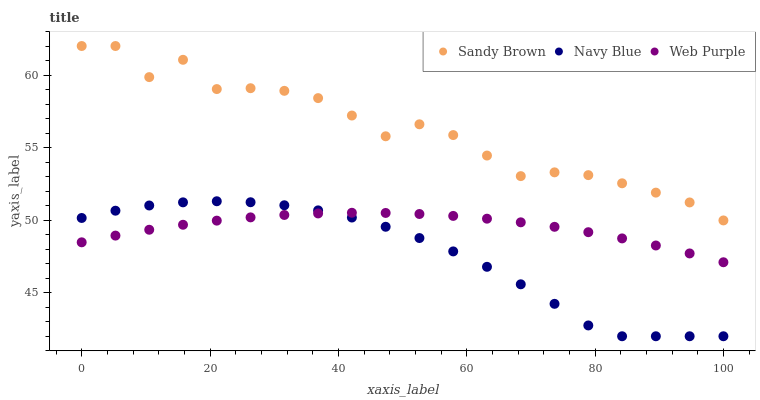Does Navy Blue have the minimum area under the curve?
Answer yes or no. Yes. Does Sandy Brown have the maximum area under the curve?
Answer yes or no. Yes. Does Web Purple have the minimum area under the curve?
Answer yes or no. No. Does Web Purple have the maximum area under the curve?
Answer yes or no. No. Is Web Purple the smoothest?
Answer yes or no. Yes. Is Sandy Brown the roughest?
Answer yes or no. Yes. Is Sandy Brown the smoothest?
Answer yes or no. No. Is Web Purple the roughest?
Answer yes or no. No. Does Navy Blue have the lowest value?
Answer yes or no. Yes. Does Web Purple have the lowest value?
Answer yes or no. No. Does Sandy Brown have the highest value?
Answer yes or no. Yes. Does Web Purple have the highest value?
Answer yes or no. No. Is Navy Blue less than Sandy Brown?
Answer yes or no. Yes. Is Sandy Brown greater than Navy Blue?
Answer yes or no. Yes. Does Navy Blue intersect Web Purple?
Answer yes or no. Yes. Is Navy Blue less than Web Purple?
Answer yes or no. No. Is Navy Blue greater than Web Purple?
Answer yes or no. No. Does Navy Blue intersect Sandy Brown?
Answer yes or no. No. 